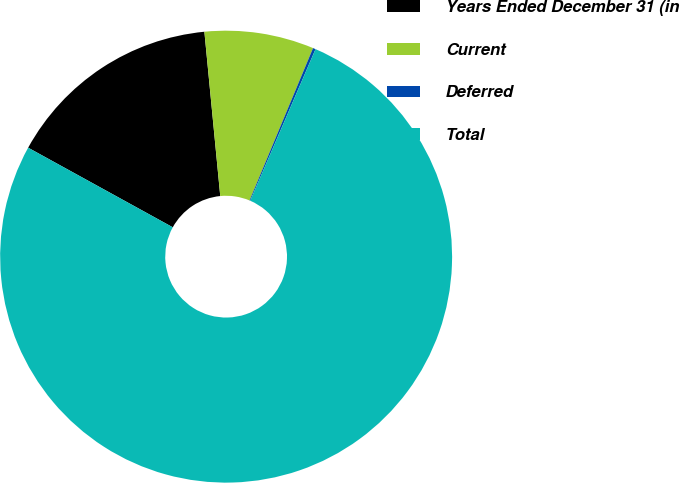<chart> <loc_0><loc_0><loc_500><loc_500><pie_chart><fcel>Years Ended December 31 (in<fcel>Current<fcel>Deferred<fcel>Total<nl><fcel>15.46%<fcel>7.82%<fcel>0.19%<fcel>76.54%<nl></chart> 